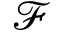Convert formula to latex. <formula><loc_0><loc_0><loc_500><loc_500>\mathcal { F }</formula> 